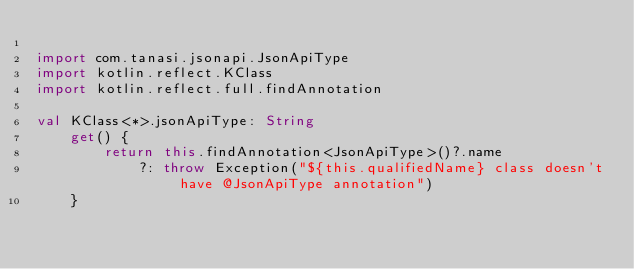Convert code to text. <code><loc_0><loc_0><loc_500><loc_500><_Kotlin_>
import com.tanasi.jsonapi.JsonApiType
import kotlin.reflect.KClass
import kotlin.reflect.full.findAnnotation

val KClass<*>.jsonApiType: String
    get() {
        return this.findAnnotation<JsonApiType>()?.name
            ?: throw Exception("${this.qualifiedName} class doesn't have @JsonApiType annotation")
    }</code> 